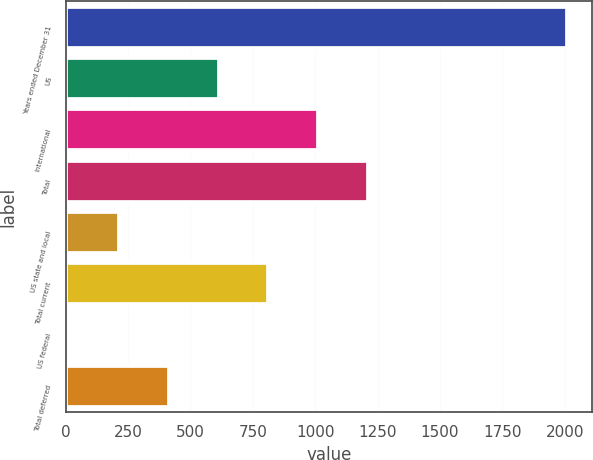Convert chart to OTSL. <chart><loc_0><loc_0><loc_500><loc_500><bar_chart><fcel>Years ended December 31<fcel>US<fcel>International<fcel>Total<fcel>US state and local<fcel>Total current<fcel>US federal<fcel>Total deferred<nl><fcel>2008<fcel>612.9<fcel>1011.5<fcel>1210.8<fcel>214.3<fcel>812.2<fcel>15<fcel>413.6<nl></chart> 